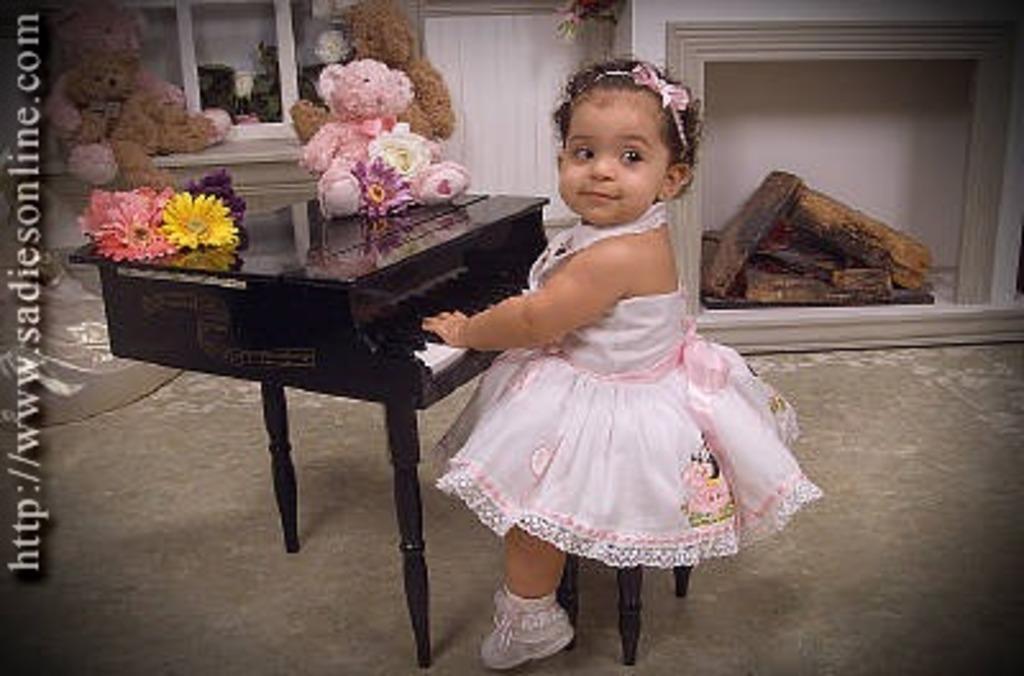Please provide a concise description of this image. This picture shows a girl sitting on the stool in front of a small piano on which some teddy bears and flowers were placed. In the background there is a good place for fire. We can observe some teddy bears on the table here. 